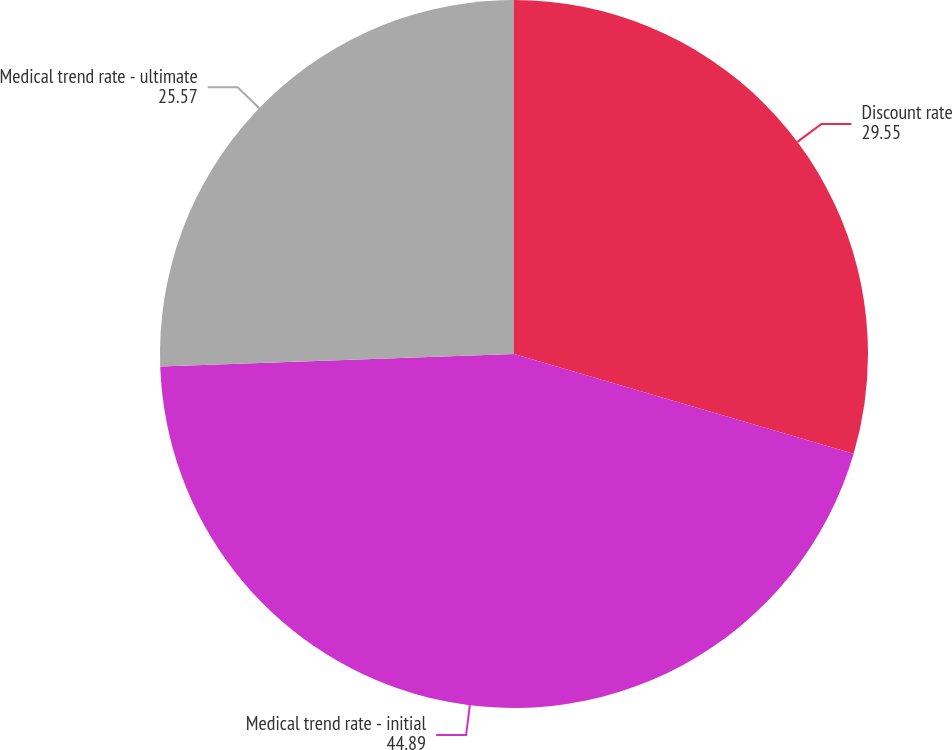<chart> <loc_0><loc_0><loc_500><loc_500><pie_chart><fcel>Discount rate<fcel>Medical trend rate - initial<fcel>Medical trend rate - ultimate<nl><fcel>29.55%<fcel>44.89%<fcel>25.57%<nl></chart> 